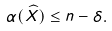<formula> <loc_0><loc_0><loc_500><loc_500>\alpha ( \widehat { X } ) \leq n - \delta .</formula> 